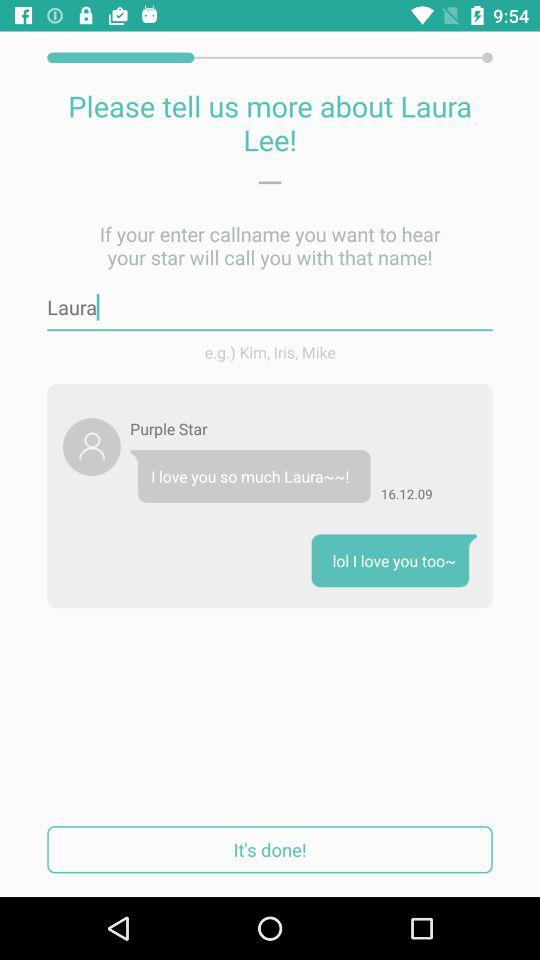When was the message received from Purple Star? The message was received on 16.12.09. 